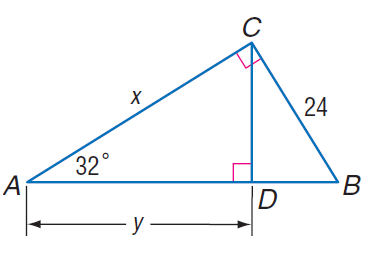Answer the mathemtical geometry problem and directly provide the correct option letter.
Question: Find x.
Choices: A: 21.1 B: 23.4 C: 38.4 D: 45.3 C 